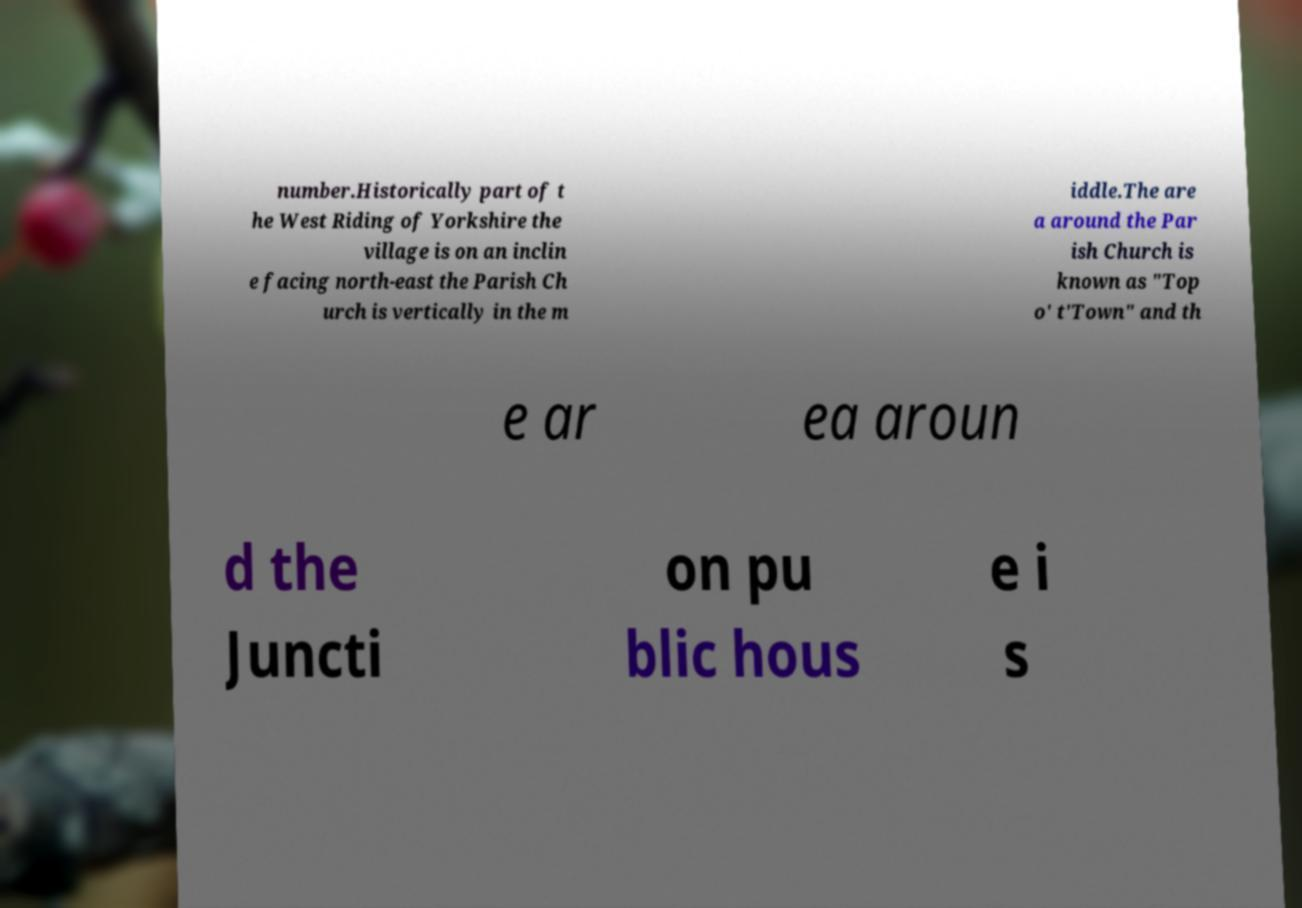Can you accurately transcribe the text from the provided image for me? number.Historically part of t he West Riding of Yorkshire the village is on an inclin e facing north-east the Parish Ch urch is vertically in the m iddle.The are a around the Par ish Church is known as "Top o' t'Town" and th e ar ea aroun d the Juncti on pu blic hous e i s 